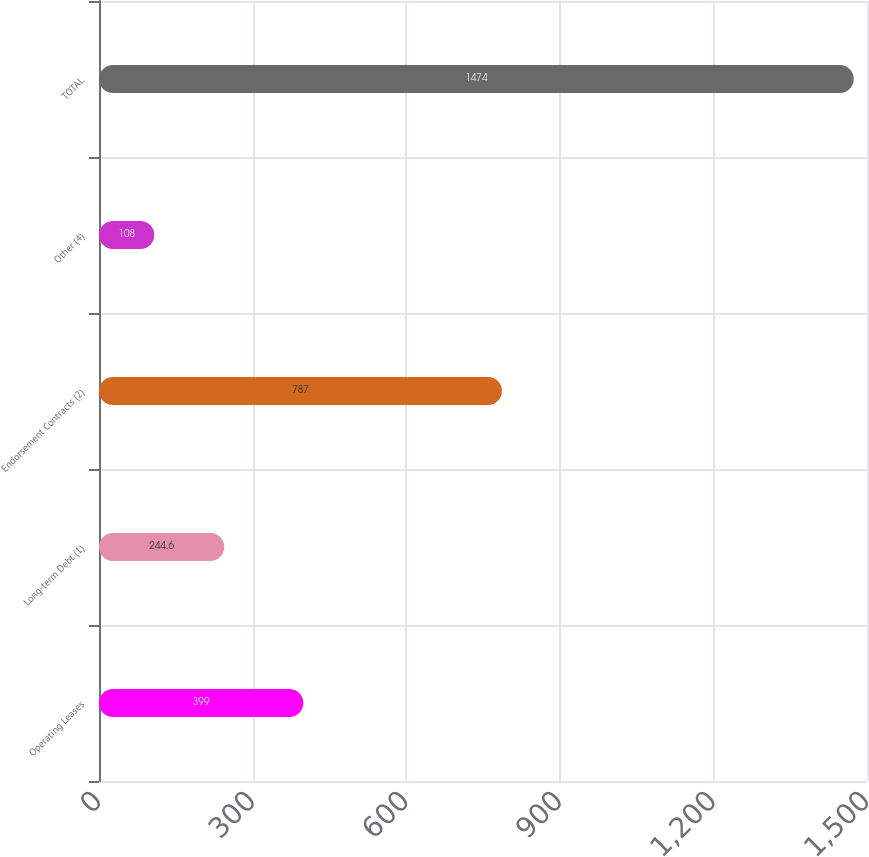Convert chart. <chart><loc_0><loc_0><loc_500><loc_500><bar_chart><fcel>Operating Leases<fcel>Long-term Debt (1)<fcel>Endorsement Contracts (2)<fcel>Other (4)<fcel>TOTAL<nl><fcel>399<fcel>244.6<fcel>787<fcel>108<fcel>1474<nl></chart> 